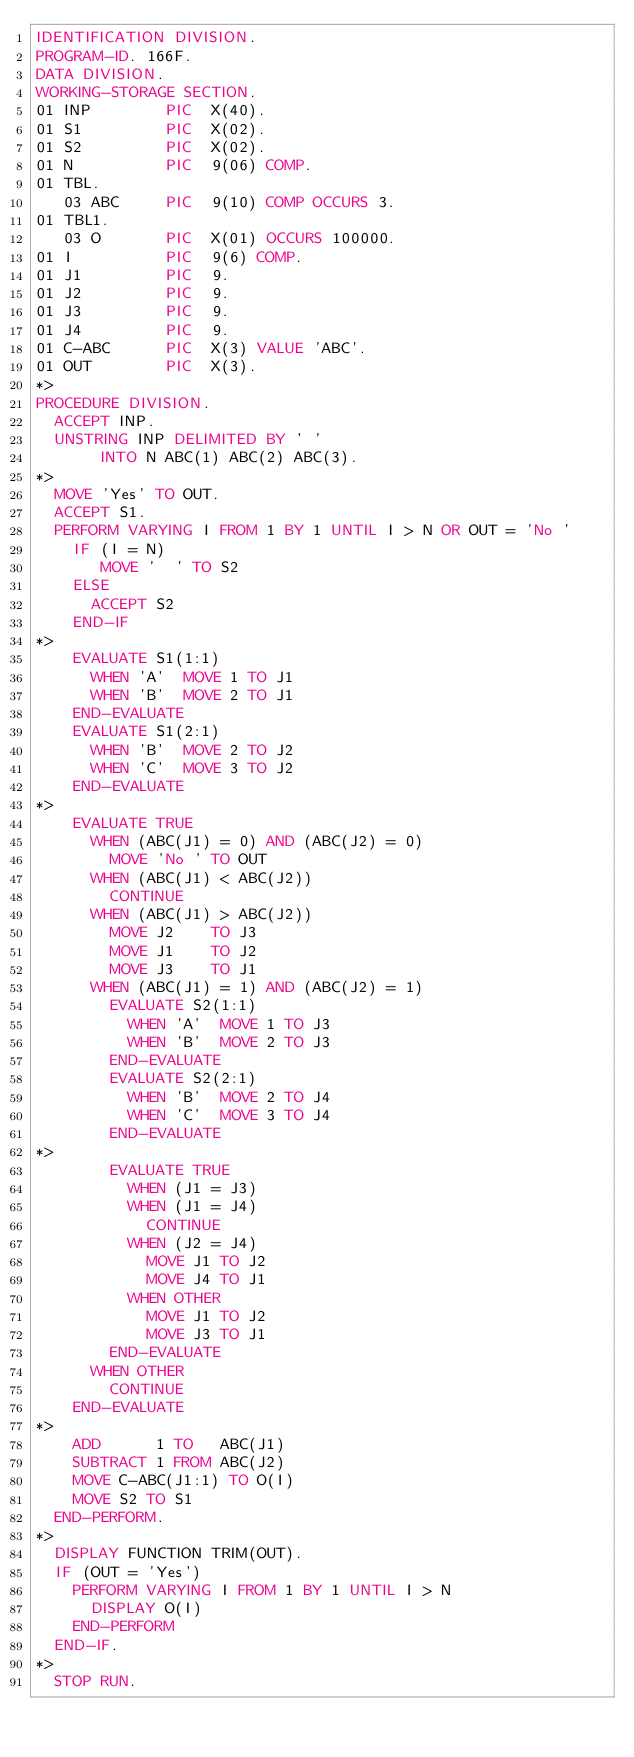<code> <loc_0><loc_0><loc_500><loc_500><_COBOL_>IDENTIFICATION DIVISION.
PROGRAM-ID. 166F.
DATA DIVISION.
WORKING-STORAGE SECTION.
01 INP        PIC  X(40).
01 S1         PIC  X(02).
01 S2         PIC  X(02).
01 N          PIC  9(06) COMP.
01 TBL.
   03 ABC     PIC  9(10) COMP OCCURS 3.
01 TBL1.
   03 O       PIC  X(01) OCCURS 100000.
01 I          PIC  9(6) COMP.
01 J1         PIC  9.
01 J2         PIC  9.
01 J3         PIC  9.
01 J4         PIC  9.
01 C-ABC      PIC  X(3) VALUE 'ABC'.
01 OUT        PIC  X(3).
*> 
PROCEDURE DIVISION.
  ACCEPT INP.
  UNSTRING INP DELIMITED BY ' '
       INTO N ABC(1) ABC(2) ABC(3).
*>
  MOVE 'Yes' TO OUT.
  ACCEPT S1.
  PERFORM VARYING I FROM 1 BY 1 UNTIL I > N OR OUT = 'No '
    IF (I = N) 
       MOVE '  ' TO S2
    ELSE
      ACCEPT S2
    END-IF
*>
    EVALUATE S1(1:1)
      WHEN 'A'  MOVE 1 TO J1
      WHEN 'B'  MOVE 2 TO J1
    END-EVALUATE
    EVALUATE S1(2:1)
      WHEN 'B'  MOVE 2 TO J2
      WHEN 'C'  MOVE 3 TO J2
    END-EVALUATE
*>
    EVALUATE TRUE
      WHEN (ABC(J1) = 0) AND (ABC(J2) = 0)
        MOVE 'No ' TO OUT
      WHEN (ABC(J1) < ABC(J2))
        CONTINUE
      WHEN (ABC(J1) > ABC(J2))
        MOVE J2    TO J3
        MOVE J1    TO J2
        MOVE J3    TO J1
      WHEN (ABC(J1) = 1) AND (ABC(J2) = 1)
        EVALUATE S2(1:1)
          WHEN 'A'  MOVE 1 TO J3
          WHEN 'B'  MOVE 2 TO J3
        END-EVALUATE
        EVALUATE S2(2:1)
          WHEN 'B'  MOVE 2 TO J4
          WHEN 'C'  MOVE 3 TO J4
        END-EVALUATE
*>
        EVALUATE TRUE            
          WHEN (J1 = J3)
          WHEN (J1 = J4)
            CONTINUE
          WHEN (J2 = J4)
            MOVE J1 TO J2
            MOVE J4 TO J1
          WHEN OTHER
            MOVE J1 TO J2
            MOVE J3 TO J1
        END-EVALUATE
      WHEN OTHER
        CONTINUE
    END-EVALUATE
*>
    ADD      1 TO   ABC(J1)
    SUBTRACT 1 FROM ABC(J2)
    MOVE C-ABC(J1:1) TO O(I)
    MOVE S2 TO S1
  END-PERFORM.
*>
  DISPLAY FUNCTION TRIM(OUT).
  IF (OUT = 'Yes')
    PERFORM VARYING I FROM 1 BY 1 UNTIL I > N
      DISPLAY O(I)
    END-PERFORM
  END-IF.
*>
  STOP RUN.
</code> 